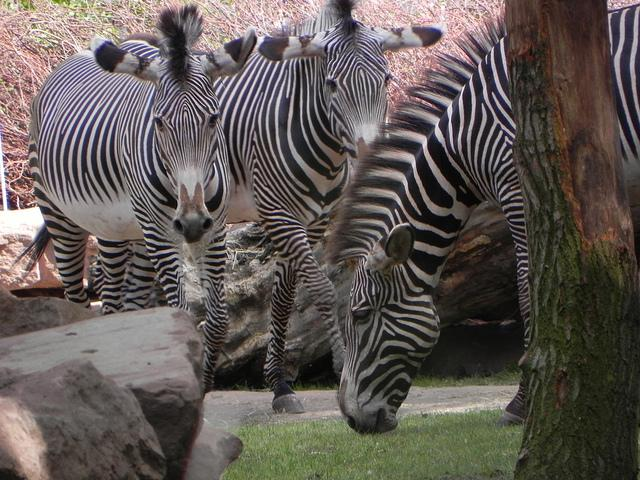What animals are most similar to these?

Choices:
A) bison
B) horses
C) wolves
D) foxes horses 